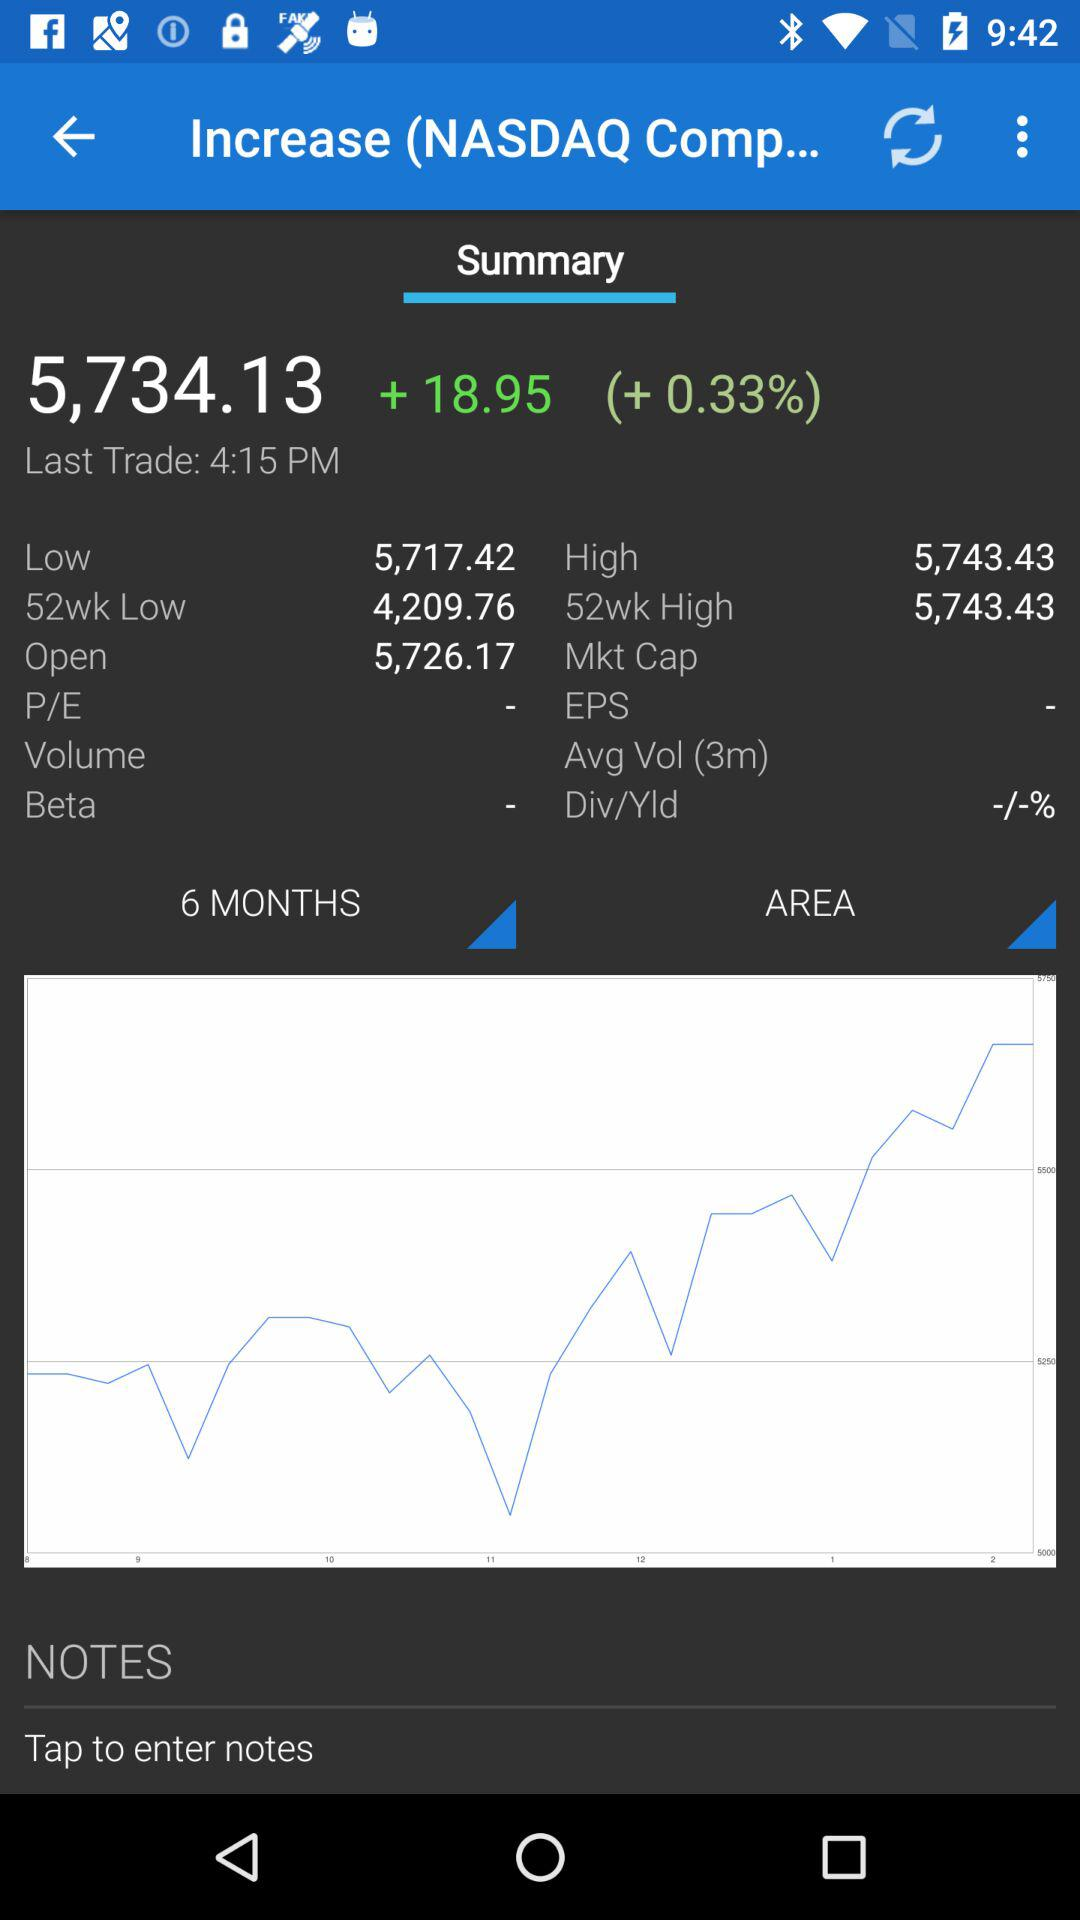At what value NASDAQ opened? NASDAQ is open at 5,726.17. 